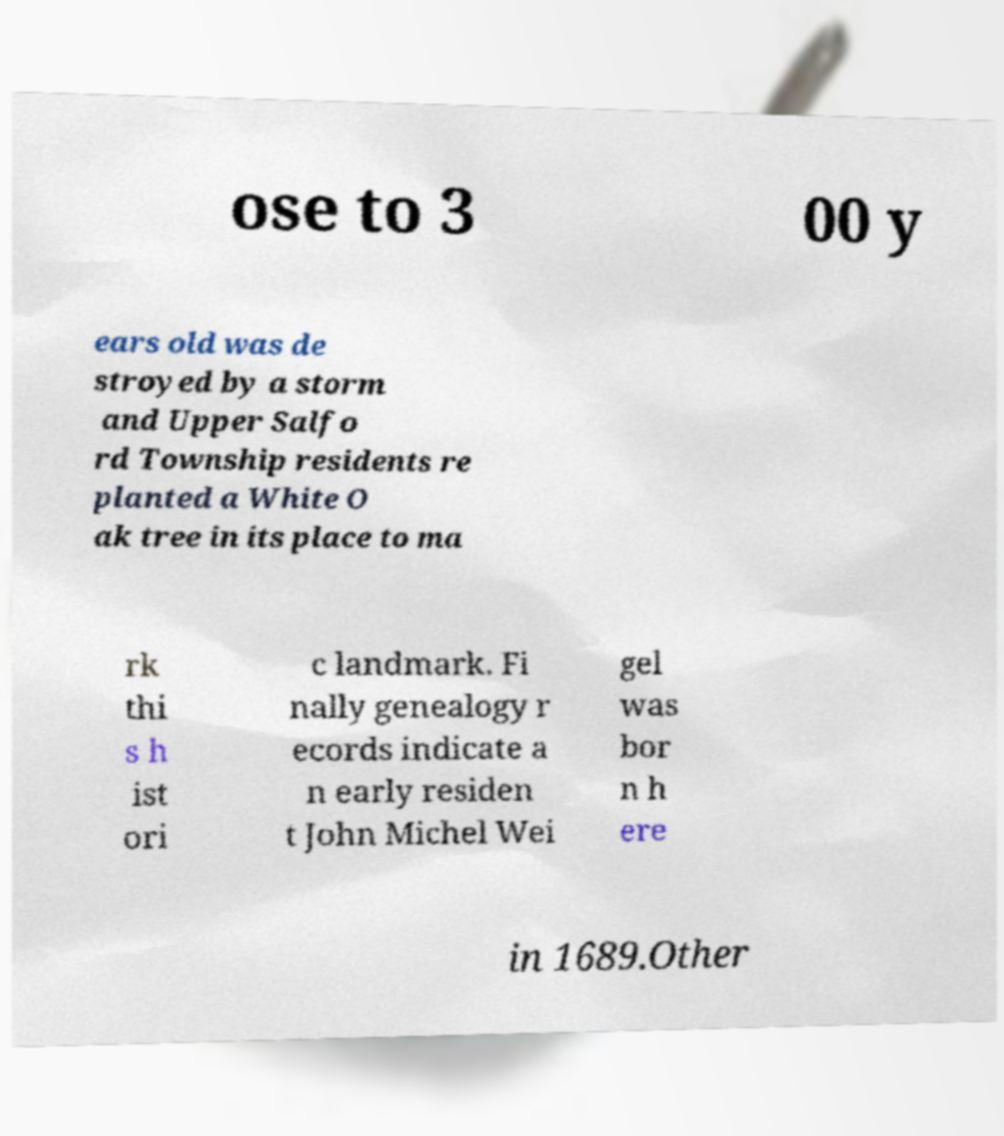Please identify and transcribe the text found in this image. ose to 3 00 y ears old was de stroyed by a storm and Upper Salfo rd Township residents re planted a White O ak tree in its place to ma rk thi s h ist ori c landmark. Fi nally genealogy r ecords indicate a n early residen t John Michel Wei gel was bor n h ere in 1689.Other 